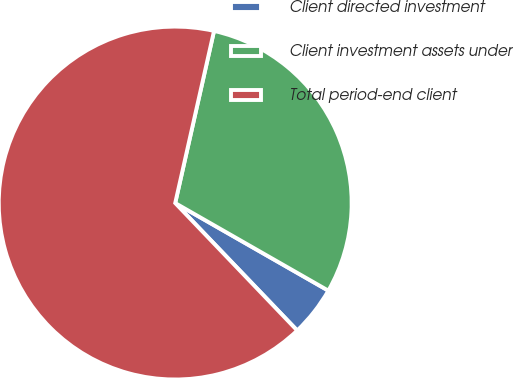Convert chart. <chart><loc_0><loc_0><loc_500><loc_500><pie_chart><fcel>Client directed investment<fcel>Client investment assets under<fcel>Total period-end client<nl><fcel>4.58%<fcel>29.74%<fcel>65.69%<nl></chart> 